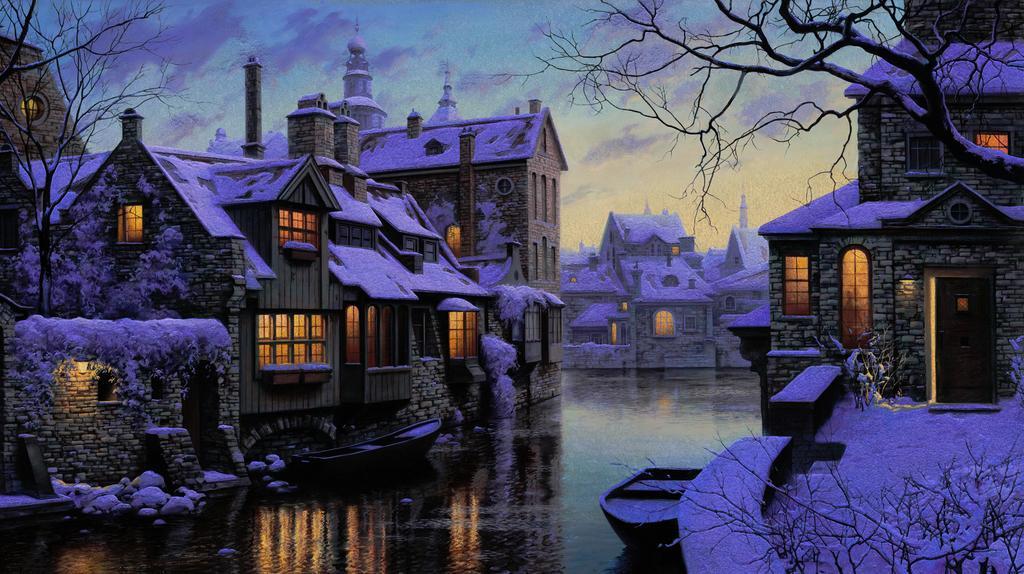Please provide a concise description of this image. In this image we can see buildings covered by snow. At the bottom there is water and we can see boats on the water. There are trees. In the background there is sky. 